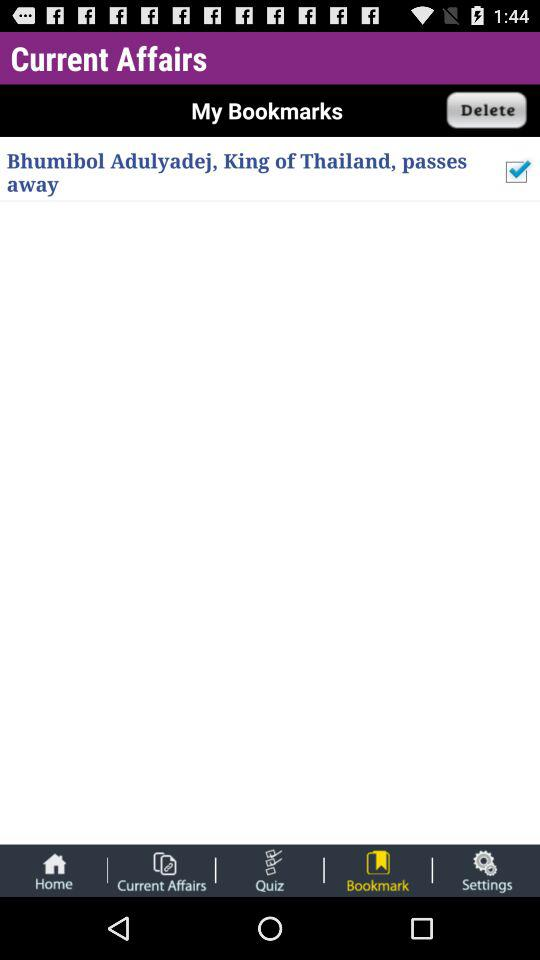What is the status of "Bhumibol Adulyadej, King of Thailand, passes away"? The status of "Bhumibol Adulyadej, King of Thailand, passes away" is "on". 